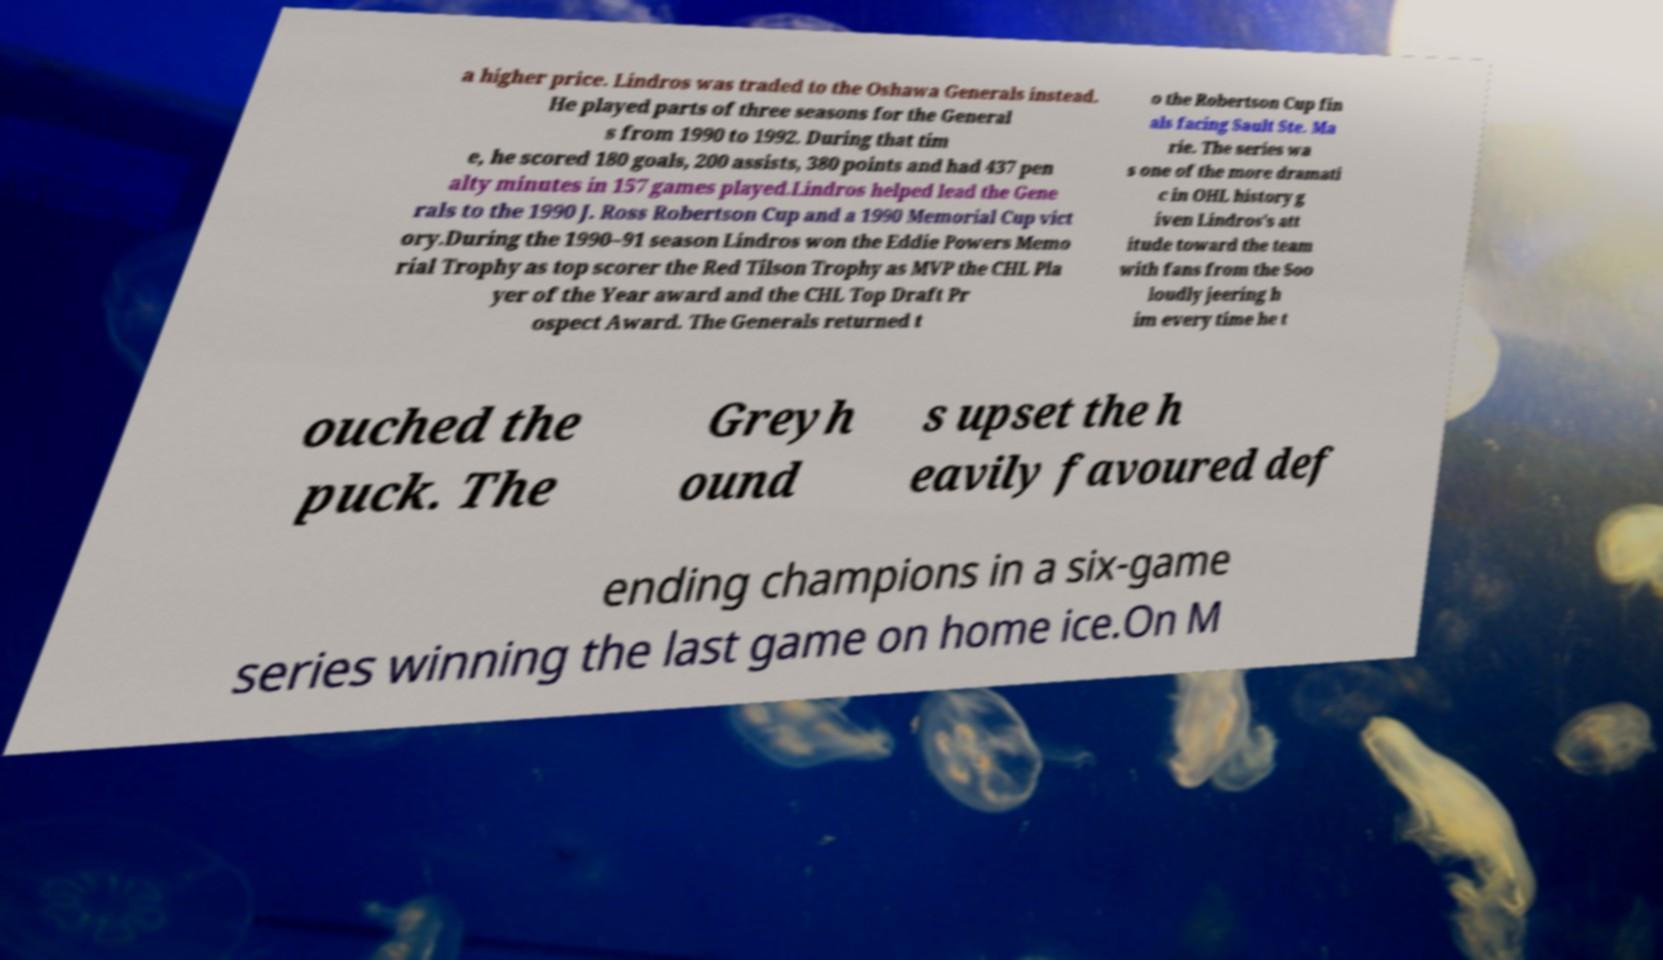For documentation purposes, I need the text within this image transcribed. Could you provide that? a higher price. Lindros was traded to the Oshawa Generals instead. He played parts of three seasons for the General s from 1990 to 1992. During that tim e, he scored 180 goals, 200 assists, 380 points and had 437 pen alty minutes in 157 games played.Lindros helped lead the Gene rals to the 1990 J. Ross Robertson Cup and a 1990 Memorial Cup vict ory.During the 1990–91 season Lindros won the Eddie Powers Memo rial Trophy as top scorer the Red Tilson Trophy as MVP the CHL Pla yer of the Year award and the CHL Top Draft Pr ospect Award. The Generals returned t o the Robertson Cup fin als facing Sault Ste. Ma rie. The series wa s one of the more dramati c in OHL history g iven Lindros's att itude toward the team with fans from the Soo loudly jeering h im every time he t ouched the puck. The Greyh ound s upset the h eavily favoured def ending champions in a six-game series winning the last game on home ice.On M 